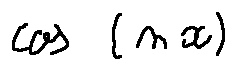<formula> <loc_0><loc_0><loc_500><loc_500>\cos ( n x )</formula> 